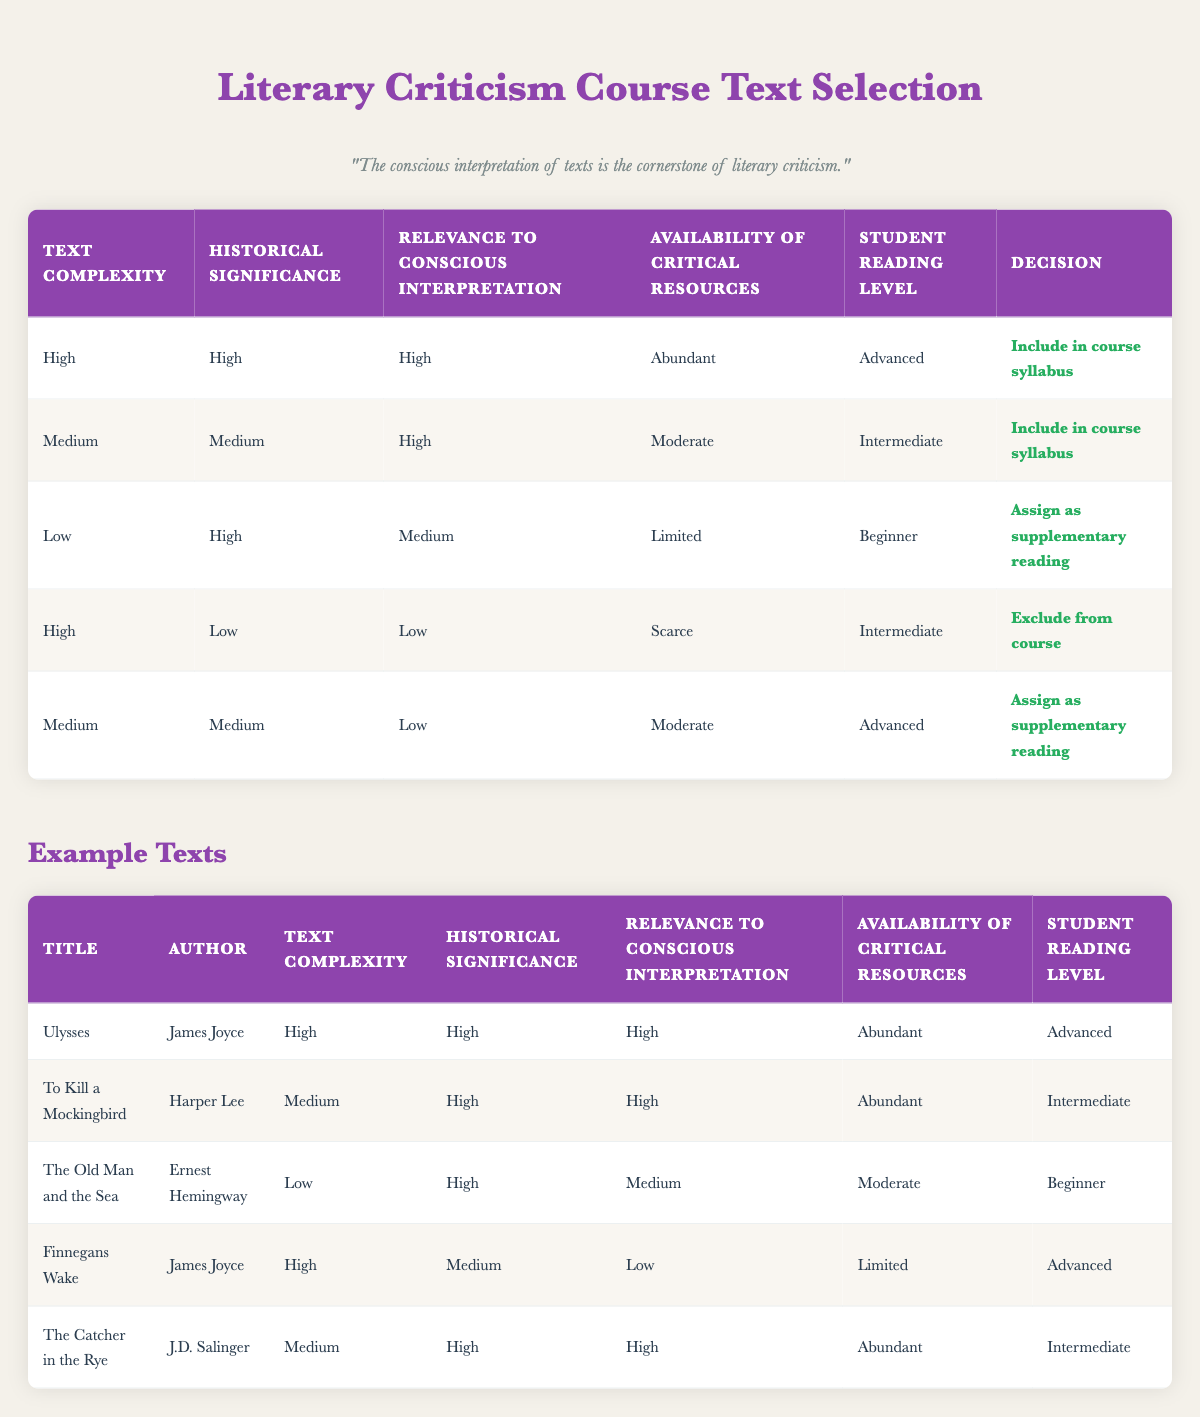What is the decision for a text with high complexity, high historical significance, high relevance to conscious interpretation, abundant critical resources, and an advanced student reading level? According to the table, this combination matches the first rule. The decision listed for these criteria is to "Include in course syllabus."
Answer: Include in course syllabus Which text is assigned as supplementary reading? The table lists "The Old Man and the Sea" under the conditions of low complexity, high historical significance, medium relevance to conscious interpretation, limited availability of critical resources, and beginner student reading level, leading to it being assigned as supplementary reading.
Answer: The Old Man and the Sea Is there any text that is excluded from the course due to low relevance to conscious interpretation? Yes, "Finnegans Wake" is excluded from the course because it has high complexity, low historical significance, low relevance to conscious interpretation, scarce resources, and an advanced reading level.
Answer: Yes What is the total number of texts included in the course syllabus? There are two texts that are included in the course syllabus: "Ulysses" and "To Kill a Mockingbird." Therefore, the total number is 2.
Answer: 2 Which text has a decision to assign it as supplementary reading despite having medium relevance to conscious interpretation? "The Old Man and the Sea" meets the criteria of low complexity, high historical significance, medium relevance to conscious interpretation, limited resources, and a beginner reading level, resulting in a decision to assign it as supplementary reading.
Answer: The Old Man and the Sea What’s the average complexity level of texts that are included in the course syllabus? The complexity levels for texts included in the course syllabus are high for both "Ulysses" and "To Kill a Mockingbird" (considered as 3) and medium for the other, leading to an average of (3 + 2) / 2 = 2.5, so it would be considered as medium (2).
Answer: Medium How many texts are assigned as supplementary reading? Based on the table, "The Old Man and the Sea" and another text, "Medium" from the last rule meets the criteria to be assigned as supplementary reading, leading to a total of 2.
Answer: 2 Is "The Catcher in the Rye" included in the course syllabus? No, "The Catcher in the Rye" does not qualify for inclusion in the course syllabus based on the conditions provided in the table, as it has only medium relevance related to conscious interpretation criteria, which disqualifies it from being included.
Answer: No 